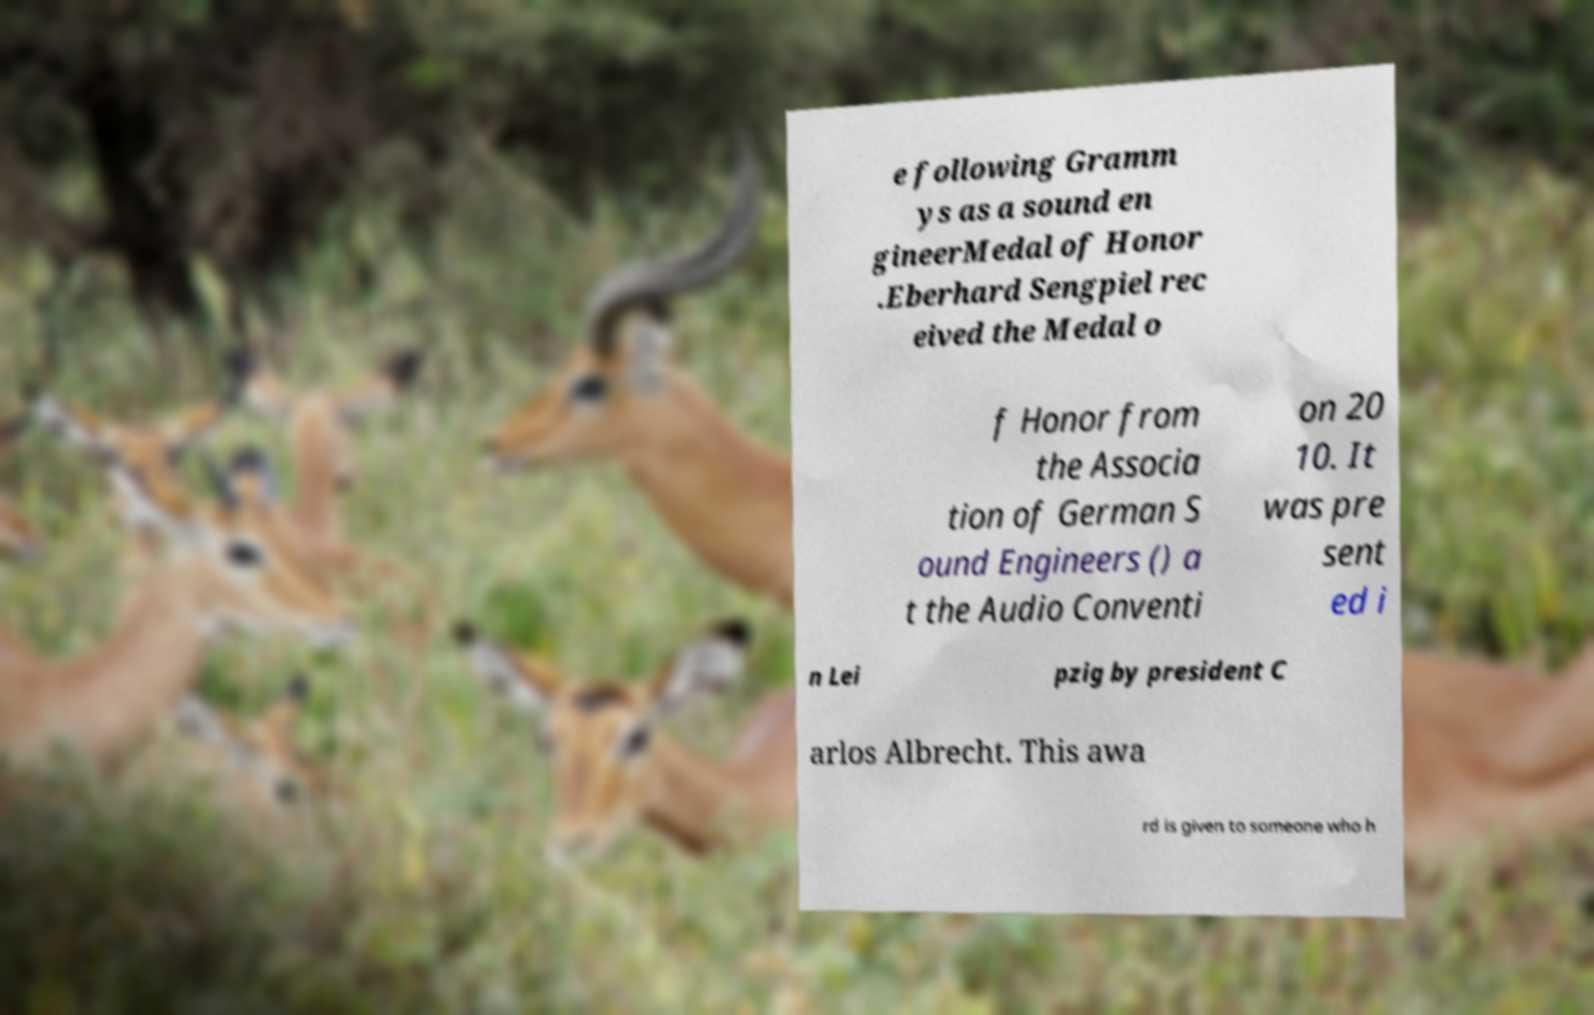Could you extract and type out the text from this image? e following Gramm ys as a sound en gineerMedal of Honor .Eberhard Sengpiel rec eived the Medal o f Honor from the Associa tion of German S ound Engineers () a t the Audio Conventi on 20 10. It was pre sent ed i n Lei pzig by president C arlos Albrecht. This awa rd is given to someone who h 